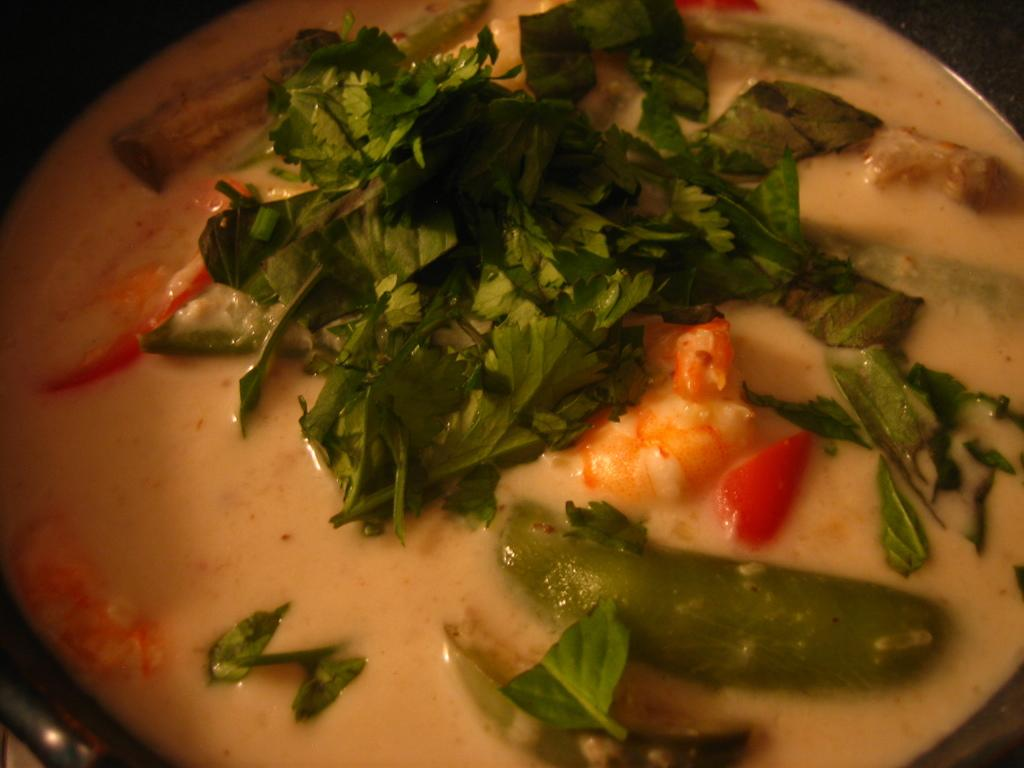What is present in the container in the image? There is food in a container in the image. What type of weather is depicted in the image? There is no weather depicted in the image, as it only shows a container with food. What organization is responsible for the food in the image? There is no information about an organization responsible for the food in the image. 